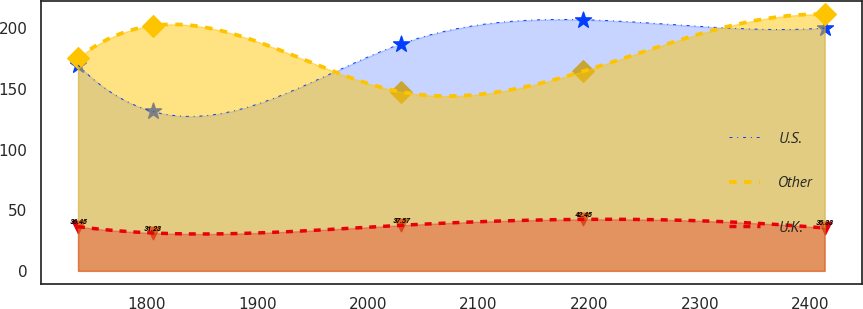Convert chart. <chart><loc_0><loc_0><loc_500><loc_500><line_chart><ecel><fcel>U.S.<fcel>Other<fcel>U.K.<nl><fcel>1737.8<fcel>169.62<fcel>175.46<fcel>36.45<nl><fcel>1805.3<fcel>131.43<fcel>202.19<fcel>31.23<nl><fcel>2030.26<fcel>187.31<fcel>147.5<fcel>37.57<nl><fcel>2194.43<fcel>207.06<fcel>164.54<fcel>42.45<nl><fcel>2412.84<fcel>200.15<fcel>211.47<fcel>35.33<nl></chart> 